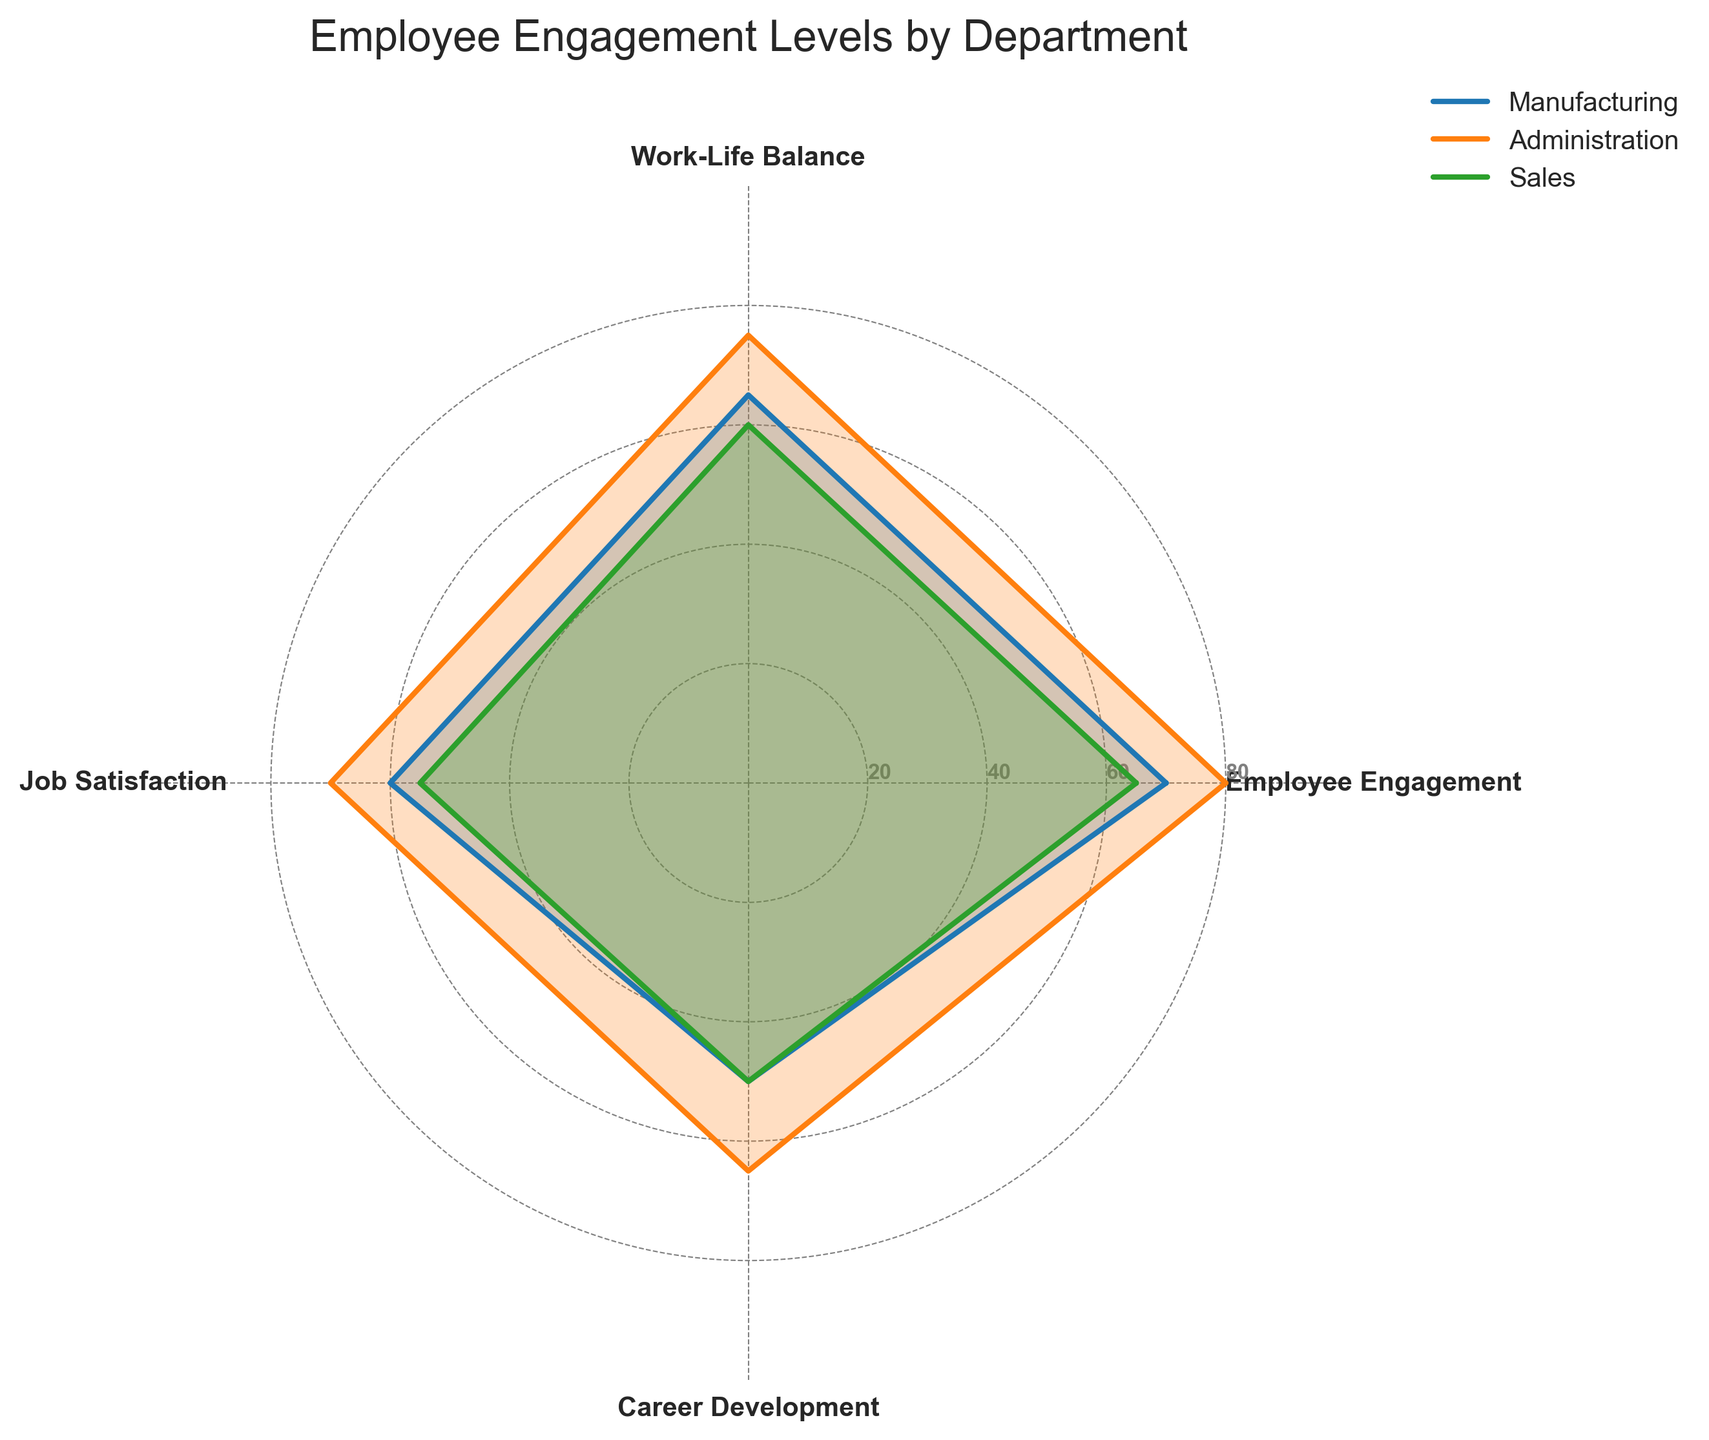Which department has the highest Employee Engagement? On the radar chart, locate the 'Employee Engagement' axis and find the department curve that reaches the highest point. Administration's curve reaches level 80.
Answer: Administration Which department has the lowest Job Satisfaction? On the radar chart, locate the 'Job Satisfaction' axis and find the department curve that reaches the lowest point. Sales' curve reaches level 55.
Answer: Sales What is the difference in Work-Life Balance between Manufacturing and Administration? Locate the 'Work-Life Balance' axis and find the values for Manufacturing and Administration. Manufacturing is at 65, and Administration is at 75. The difference is 75 - 65.
Answer: 10 What is the average Career Development score across all departments? Find the 'Career Development' axis and read the values for Manufacturing (50), Administration (65), and Sales (50). Calculate the average: (50 + 65 + 50) / 3.
Answer: 55 Which department shows the most balanced performance across all metrics? Assess each department's curve's balance across categories. Administration's curve is relatively balanced with scores close to each other compared to the other departments.
Answer: Administration Which category shows the least variation in scores across departments? Compare the spread of scores among 'Employee Engagement', 'Work-Life Balance', 'Job Satisfaction', and 'Career Development'. 'Career Development' has the smallest range (50 to 65).
Answer: Career Development How do the Career Development scores compare between Sales and Manufacturing? Locate the 'Career Development' axis and compare the points for Sales and Manufacturing. Both are at 50.
Answer: Equal What is the sum of the Employee Engagement levels for all departments? Find the 'Employee Engagement' values for Manufacturing (70), Administration (80), and Sales (65). Add them together: 70 + 80 + 65.
Answer: 215 Which department has the steepest drop in scores from Employee Engagement to Career Development? Compare the drop in scores from 'Employee Engagement' to 'Career Development' for each department. Manufacturing drops from 70 to 50, Sales also from 65 to 50, and Administration from 80 to 65. Manufacturing and Sales have the steepest drop, both dropping by 20 points.
Answer: Manufacturing and Sales 